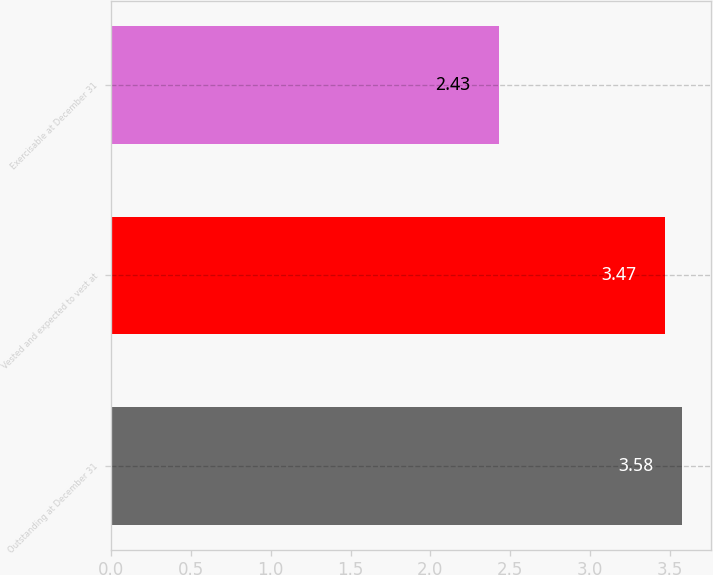Convert chart. <chart><loc_0><loc_0><loc_500><loc_500><bar_chart><fcel>Outstanding at December 31<fcel>Vested and expected to vest at<fcel>Exercisable at December 31<nl><fcel>3.58<fcel>3.47<fcel>2.43<nl></chart> 